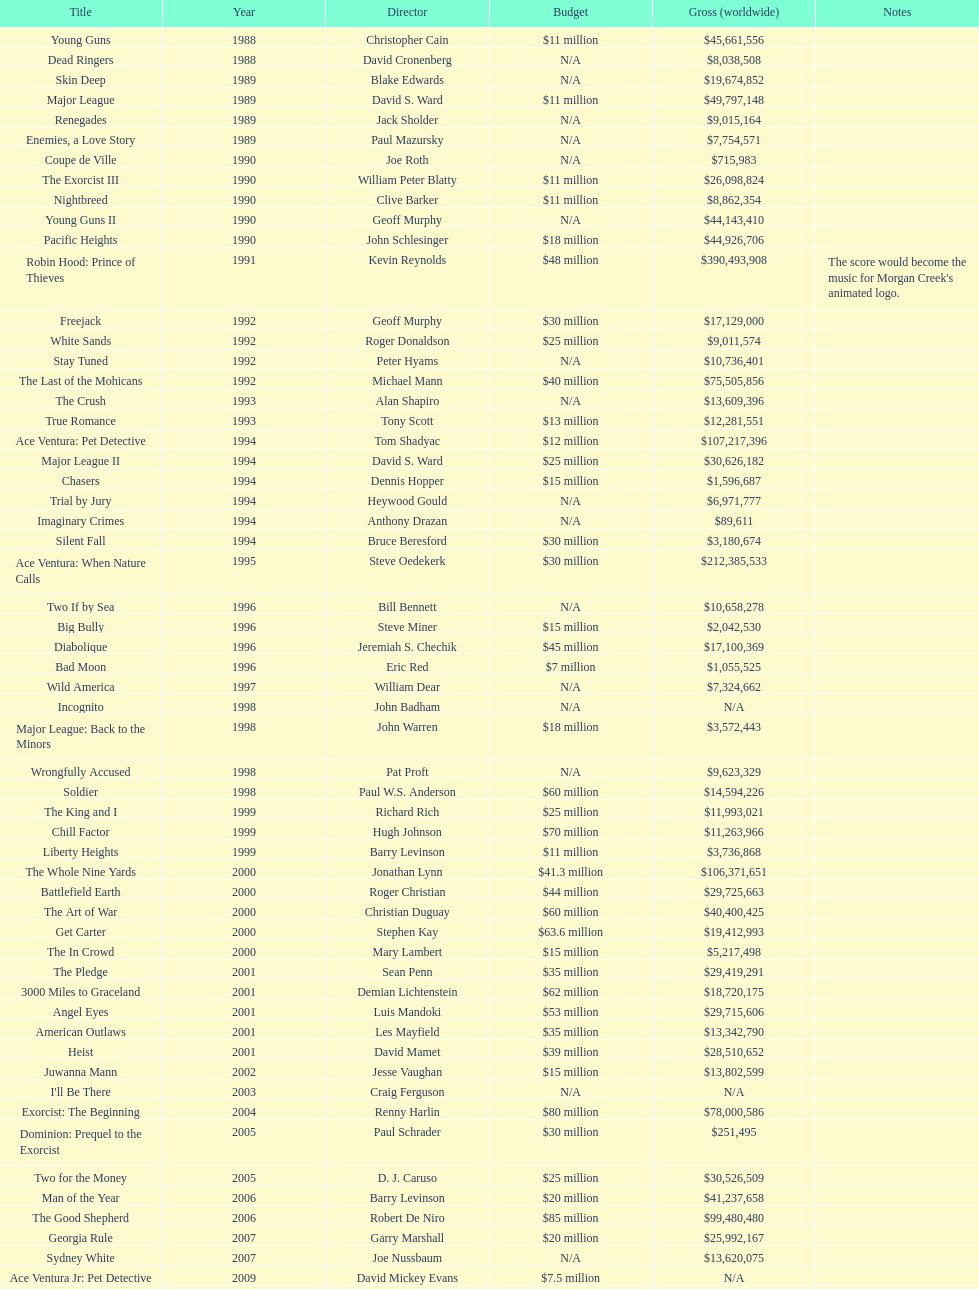Can you parse all the data within this table? {'header': ['Title', 'Year', 'Director', 'Budget', 'Gross (worldwide)', 'Notes'], 'rows': [['Young Guns', '1988', 'Christopher Cain', '$11 million', '$45,661,556', ''], ['Dead Ringers', '1988', 'David Cronenberg', 'N/A', '$8,038,508', ''], ['Skin Deep', '1989', 'Blake Edwards', 'N/A', '$19,674,852', ''], ['Major League', '1989', 'David S. Ward', '$11 million', '$49,797,148', ''], ['Renegades', '1989', 'Jack Sholder', 'N/A', '$9,015,164', ''], ['Enemies, a Love Story', '1989', 'Paul Mazursky', 'N/A', '$7,754,571', ''], ['Coupe de Ville', '1990', 'Joe Roth', 'N/A', '$715,983', ''], ['The Exorcist III', '1990', 'William Peter Blatty', '$11 million', '$26,098,824', ''], ['Nightbreed', '1990', 'Clive Barker', '$11 million', '$8,862,354', ''], ['Young Guns II', '1990', 'Geoff Murphy', 'N/A', '$44,143,410', ''], ['Pacific Heights', '1990', 'John Schlesinger', '$18 million', '$44,926,706', ''], ['Robin Hood: Prince of Thieves', '1991', 'Kevin Reynolds', '$48 million', '$390,493,908', "The score would become the music for Morgan Creek's animated logo."], ['Freejack', '1992', 'Geoff Murphy', '$30 million', '$17,129,000', ''], ['White Sands', '1992', 'Roger Donaldson', '$25 million', '$9,011,574', ''], ['Stay Tuned', '1992', 'Peter Hyams', 'N/A', '$10,736,401', ''], ['The Last of the Mohicans', '1992', 'Michael Mann', '$40 million', '$75,505,856', ''], ['The Crush', '1993', 'Alan Shapiro', 'N/A', '$13,609,396', ''], ['True Romance', '1993', 'Tony Scott', '$13 million', '$12,281,551', ''], ['Ace Ventura: Pet Detective', '1994', 'Tom Shadyac', '$12 million', '$107,217,396', ''], ['Major League II', '1994', 'David S. Ward', '$25 million', '$30,626,182', ''], ['Chasers', '1994', 'Dennis Hopper', '$15 million', '$1,596,687', ''], ['Trial by Jury', '1994', 'Heywood Gould', 'N/A', '$6,971,777', ''], ['Imaginary Crimes', '1994', 'Anthony Drazan', 'N/A', '$89,611', ''], ['Silent Fall', '1994', 'Bruce Beresford', '$30 million', '$3,180,674', ''], ['Ace Ventura: When Nature Calls', '1995', 'Steve Oedekerk', '$30 million', '$212,385,533', ''], ['Two If by Sea', '1996', 'Bill Bennett', 'N/A', '$10,658,278', ''], ['Big Bully', '1996', 'Steve Miner', '$15 million', '$2,042,530', ''], ['Diabolique', '1996', 'Jeremiah S. Chechik', '$45 million', '$17,100,369', ''], ['Bad Moon', '1996', 'Eric Red', '$7 million', '$1,055,525', ''], ['Wild America', '1997', 'William Dear', 'N/A', '$7,324,662', ''], ['Incognito', '1998', 'John Badham', 'N/A', 'N/A', ''], ['Major League: Back to the Minors', '1998', 'John Warren', '$18 million', '$3,572,443', ''], ['Wrongfully Accused', '1998', 'Pat Proft', 'N/A', '$9,623,329', ''], ['Soldier', '1998', 'Paul W.S. Anderson', '$60 million', '$14,594,226', ''], ['The King and I', '1999', 'Richard Rich', '$25 million', '$11,993,021', ''], ['Chill Factor', '1999', 'Hugh Johnson', '$70 million', '$11,263,966', ''], ['Liberty Heights', '1999', 'Barry Levinson', '$11 million', '$3,736,868', ''], ['The Whole Nine Yards', '2000', 'Jonathan Lynn', '$41.3 million', '$106,371,651', ''], ['Battlefield Earth', '2000', 'Roger Christian', '$44 million', '$29,725,663', ''], ['The Art of War', '2000', 'Christian Duguay', '$60 million', '$40,400,425', ''], ['Get Carter', '2000', 'Stephen Kay', '$63.6 million', '$19,412,993', ''], ['The In Crowd', '2000', 'Mary Lambert', '$15 million', '$5,217,498', ''], ['The Pledge', '2001', 'Sean Penn', '$35 million', '$29,419,291', ''], ['3000 Miles to Graceland', '2001', 'Demian Lichtenstein', '$62 million', '$18,720,175', ''], ['Angel Eyes', '2001', 'Luis Mandoki', '$53 million', '$29,715,606', ''], ['American Outlaws', '2001', 'Les Mayfield', '$35 million', '$13,342,790', ''], ['Heist', '2001', 'David Mamet', '$39 million', '$28,510,652', ''], ['Juwanna Mann', '2002', 'Jesse Vaughan', '$15 million', '$13,802,599', ''], ["I'll Be There", '2003', 'Craig Ferguson', 'N/A', 'N/A', ''], ['Exorcist: The Beginning', '2004', 'Renny Harlin', '$80 million', '$78,000,586', ''], ['Dominion: Prequel to the Exorcist', '2005', 'Paul Schrader', '$30 million', '$251,495', ''], ['Two for the Money', '2005', 'D. J. Caruso', '$25 million', '$30,526,509', ''], ['Man of the Year', '2006', 'Barry Levinson', '$20 million', '$41,237,658', ''], ['The Good Shepherd', '2006', 'Robert De Niro', '$85 million', '$99,480,480', ''], ['Georgia Rule', '2007', 'Garry Marshall', '$20 million', '$25,992,167', ''], ['Sydney White', '2007', 'Joe Nussbaum', 'N/A', '$13,620,075', ''], ['Ace Ventura Jr: Pet Detective', '2009', 'David Mickey Evans', '$7.5 million', 'N/A', ''], ['Dream House', '2011', 'Jim Sheridan', '$50 million', '$38,502,340', ''], ['The Thing', '2011', 'Matthijs van Heijningen Jr.', '$38 million', '$27,428,670', ''], ['Tupac', '2014', 'Antoine Fuqua', '$45 million', '', '']]} Which cinema work was made directly preceding the pledge? The In Crowd. 